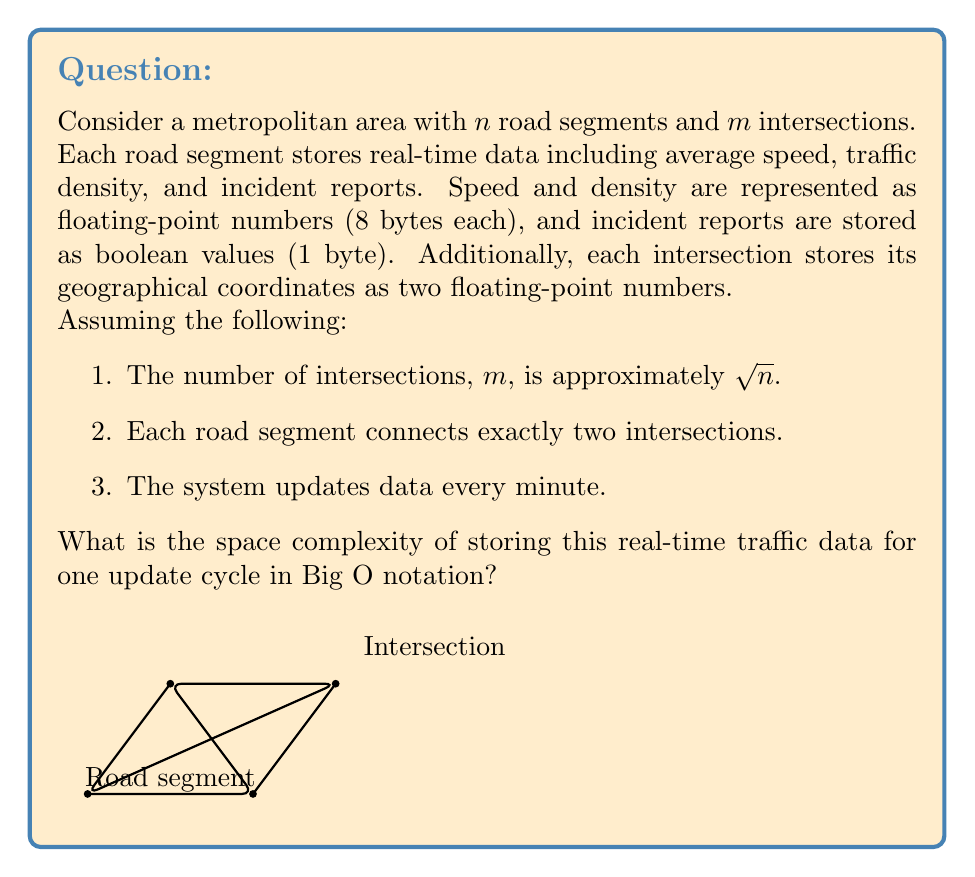Show me your answer to this math problem. Let's break down the problem and calculate the space required step-by-step:

1. Space for road segments:
   - Each road segment stores 3 pieces of information:
     * Average speed (8 bytes)
     * Traffic density (8 bytes)
     * Incident report (1 byte)
   - Total for one road segment: 8 + 8 + 1 = 17 bytes
   - For $n$ road segments: $17n$ bytes

2. Space for intersections:
   - Each intersection stores 2 coordinates (8 bytes each)
   - Total for one intersection: 16 bytes
   - Number of intersections $m \approx \sqrt{n}$
   - For all intersections: $16\sqrt{n}$ bytes

3. Total space:
   $S(n) = 17n + 16\sqrt{n}$ bytes

4. Asymptotic analysis:
   As $n$ grows large, the $\sqrt{n}$ term becomes insignificant compared to $n$.
   Therefore, $S(n)$ is asymptotically equivalent to $17n$.

5. Big O notation:
   Dropping the constant factor, we express the space complexity as $O(n)$.

This linear space complexity reflects that the storage requirement grows proportionally with the number of road segments, which is the dominant factor in the system.
Answer: $O(n)$ 